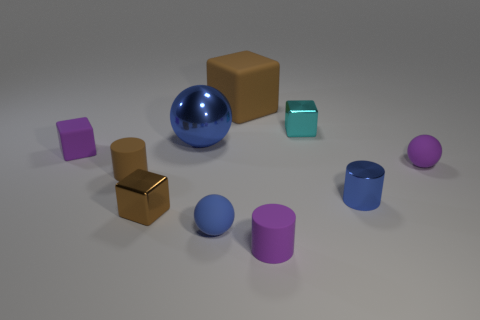Can you tell me which object stands out the most in this image? The blue reflective sphere stands out due to its vibrant color and high reflectivity, which contrasts with the matte surfaces of the other objects. 